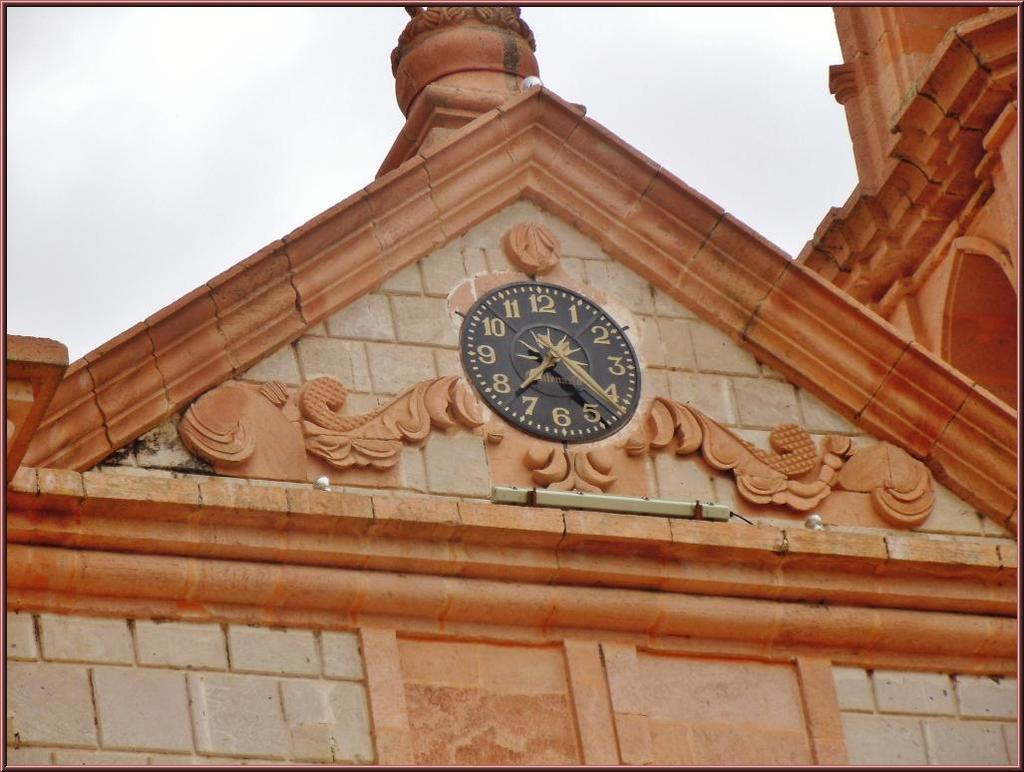Provide a one-sentence caption for the provided image. a closeup of an analog clock with numbers 1-12 on a brick building. 